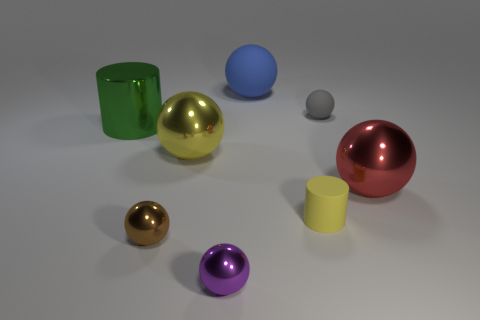There is a big object that is the same color as the matte cylinder; what is its shape?
Offer a very short reply. Sphere. What size is the thing that is the same color as the tiny rubber cylinder?
Offer a very short reply. Large. Are there any red metal balls on the left side of the tiny purple ball?
Offer a very short reply. No. There is a cylinder that is right of the big object that is left of the small thing that is left of the big yellow thing; what color is it?
Your response must be concise. Yellow. Is the yellow metal thing the same shape as the big red object?
Offer a very short reply. Yes. What color is the tiny cylinder that is made of the same material as the blue thing?
Provide a succinct answer. Yellow. How many things are metal things on the left side of the large yellow ball or big metal things?
Keep it short and to the point. 4. There is a yellow object on the left side of the big matte thing; what size is it?
Your response must be concise. Large. There is a red thing; does it have the same size as the cylinder on the right side of the big green metal object?
Your response must be concise. No. There is a big sphere right of the object behind the gray object; what color is it?
Your response must be concise. Red. 